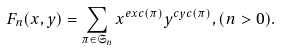Convert formula to latex. <formula><loc_0><loc_0><loc_500><loc_500>F _ { n } ( x , y ) = \sum _ { \pi \in \mathfrak { S } _ { n } } x ^ { e x c ( \pi ) } y ^ { c y c ( \pi ) } , ( n > 0 ) .</formula> 